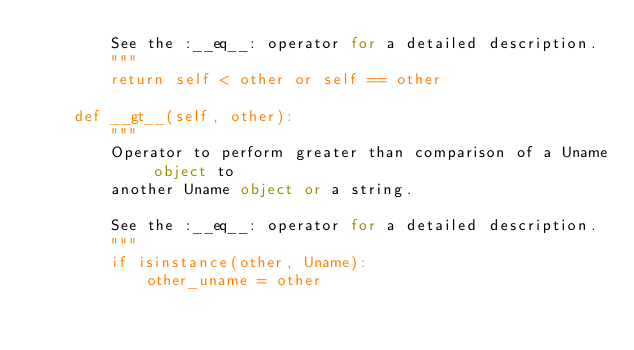<code> <loc_0><loc_0><loc_500><loc_500><_Python_>        See the :__eq__: operator for a detailed description.
        """
        return self < other or self == other

    def __gt__(self, other):
        """
        Operator to perform greater than comparison of a Uname object to
        another Uname object or a string.

        See the :__eq__: operator for a detailed description.
        """
        if isinstance(other, Uname):
            other_uname = other</code> 